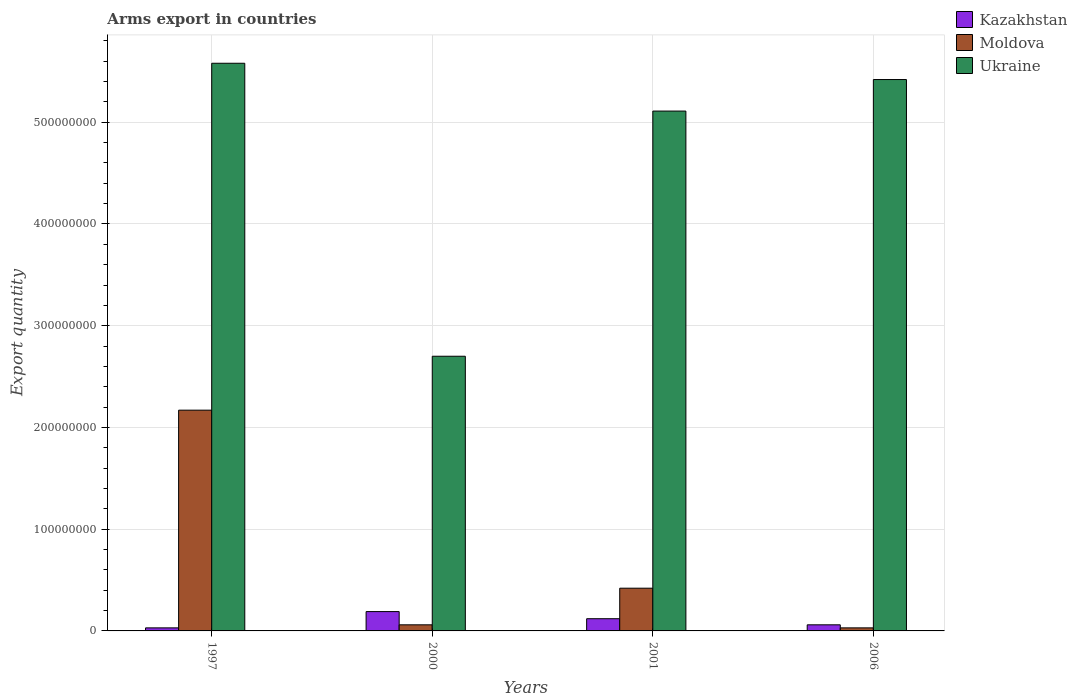In how many cases, is the number of bars for a given year not equal to the number of legend labels?
Offer a terse response. 0. What is the total arms export in Moldova in 2000?
Make the answer very short. 6.00e+06. Across all years, what is the maximum total arms export in Moldova?
Offer a very short reply. 2.17e+08. In which year was the total arms export in Kazakhstan minimum?
Ensure brevity in your answer.  1997. What is the total total arms export in Ukraine in the graph?
Give a very brief answer. 1.88e+09. What is the difference between the total arms export in Ukraine in 2000 and that in 2006?
Provide a short and direct response. -2.72e+08. What is the difference between the total arms export in Ukraine in 2000 and the total arms export in Kazakhstan in 2006?
Your response must be concise. 2.64e+08. What is the average total arms export in Moldova per year?
Your answer should be very brief. 6.70e+07. In the year 2001, what is the difference between the total arms export in Ukraine and total arms export in Kazakhstan?
Your response must be concise. 4.99e+08. What is the ratio of the total arms export in Ukraine in 2001 to that in 2006?
Your response must be concise. 0.94. Is the total arms export in Moldova in 2000 less than that in 2006?
Give a very brief answer. No. Is the difference between the total arms export in Ukraine in 2001 and 2006 greater than the difference between the total arms export in Kazakhstan in 2001 and 2006?
Offer a very short reply. No. What is the difference between the highest and the second highest total arms export in Kazakhstan?
Ensure brevity in your answer.  7.00e+06. What is the difference between the highest and the lowest total arms export in Ukraine?
Your response must be concise. 2.88e+08. In how many years, is the total arms export in Kazakhstan greater than the average total arms export in Kazakhstan taken over all years?
Your answer should be compact. 2. What does the 1st bar from the left in 2000 represents?
Your answer should be very brief. Kazakhstan. What does the 3rd bar from the right in 2000 represents?
Give a very brief answer. Kazakhstan. Are all the bars in the graph horizontal?
Give a very brief answer. No. How many years are there in the graph?
Keep it short and to the point. 4. Are the values on the major ticks of Y-axis written in scientific E-notation?
Make the answer very short. No. Does the graph contain grids?
Offer a terse response. Yes. How are the legend labels stacked?
Your answer should be compact. Vertical. What is the title of the graph?
Give a very brief answer. Arms export in countries. Does "Tanzania" appear as one of the legend labels in the graph?
Make the answer very short. No. What is the label or title of the X-axis?
Offer a very short reply. Years. What is the label or title of the Y-axis?
Your answer should be compact. Export quantity. What is the Export quantity of Moldova in 1997?
Offer a terse response. 2.17e+08. What is the Export quantity in Ukraine in 1997?
Offer a terse response. 5.58e+08. What is the Export quantity of Kazakhstan in 2000?
Keep it short and to the point. 1.90e+07. What is the Export quantity of Moldova in 2000?
Give a very brief answer. 6.00e+06. What is the Export quantity in Ukraine in 2000?
Your answer should be compact. 2.70e+08. What is the Export quantity of Moldova in 2001?
Offer a very short reply. 4.20e+07. What is the Export quantity of Ukraine in 2001?
Give a very brief answer. 5.11e+08. What is the Export quantity of Kazakhstan in 2006?
Ensure brevity in your answer.  6.00e+06. What is the Export quantity of Ukraine in 2006?
Make the answer very short. 5.42e+08. Across all years, what is the maximum Export quantity of Kazakhstan?
Provide a short and direct response. 1.90e+07. Across all years, what is the maximum Export quantity of Moldova?
Your response must be concise. 2.17e+08. Across all years, what is the maximum Export quantity in Ukraine?
Your answer should be compact. 5.58e+08. Across all years, what is the minimum Export quantity in Ukraine?
Offer a very short reply. 2.70e+08. What is the total Export quantity in Kazakhstan in the graph?
Make the answer very short. 4.00e+07. What is the total Export quantity of Moldova in the graph?
Ensure brevity in your answer.  2.68e+08. What is the total Export quantity in Ukraine in the graph?
Ensure brevity in your answer.  1.88e+09. What is the difference between the Export quantity in Kazakhstan in 1997 and that in 2000?
Provide a succinct answer. -1.60e+07. What is the difference between the Export quantity of Moldova in 1997 and that in 2000?
Offer a very short reply. 2.11e+08. What is the difference between the Export quantity of Ukraine in 1997 and that in 2000?
Offer a terse response. 2.88e+08. What is the difference between the Export quantity in Kazakhstan in 1997 and that in 2001?
Give a very brief answer. -9.00e+06. What is the difference between the Export quantity in Moldova in 1997 and that in 2001?
Your answer should be very brief. 1.75e+08. What is the difference between the Export quantity in Ukraine in 1997 and that in 2001?
Give a very brief answer. 4.70e+07. What is the difference between the Export quantity in Moldova in 1997 and that in 2006?
Ensure brevity in your answer.  2.14e+08. What is the difference between the Export quantity in Ukraine in 1997 and that in 2006?
Give a very brief answer. 1.60e+07. What is the difference between the Export quantity of Moldova in 2000 and that in 2001?
Provide a succinct answer. -3.60e+07. What is the difference between the Export quantity of Ukraine in 2000 and that in 2001?
Make the answer very short. -2.41e+08. What is the difference between the Export quantity in Kazakhstan in 2000 and that in 2006?
Offer a very short reply. 1.30e+07. What is the difference between the Export quantity in Moldova in 2000 and that in 2006?
Give a very brief answer. 3.00e+06. What is the difference between the Export quantity in Ukraine in 2000 and that in 2006?
Provide a short and direct response. -2.72e+08. What is the difference between the Export quantity of Kazakhstan in 2001 and that in 2006?
Your answer should be very brief. 6.00e+06. What is the difference between the Export quantity of Moldova in 2001 and that in 2006?
Provide a short and direct response. 3.90e+07. What is the difference between the Export quantity in Ukraine in 2001 and that in 2006?
Offer a very short reply. -3.10e+07. What is the difference between the Export quantity of Kazakhstan in 1997 and the Export quantity of Moldova in 2000?
Provide a short and direct response. -3.00e+06. What is the difference between the Export quantity in Kazakhstan in 1997 and the Export quantity in Ukraine in 2000?
Ensure brevity in your answer.  -2.67e+08. What is the difference between the Export quantity of Moldova in 1997 and the Export quantity of Ukraine in 2000?
Your answer should be very brief. -5.30e+07. What is the difference between the Export quantity of Kazakhstan in 1997 and the Export quantity of Moldova in 2001?
Keep it short and to the point. -3.90e+07. What is the difference between the Export quantity in Kazakhstan in 1997 and the Export quantity in Ukraine in 2001?
Keep it short and to the point. -5.08e+08. What is the difference between the Export quantity of Moldova in 1997 and the Export quantity of Ukraine in 2001?
Provide a short and direct response. -2.94e+08. What is the difference between the Export quantity of Kazakhstan in 1997 and the Export quantity of Ukraine in 2006?
Your answer should be very brief. -5.39e+08. What is the difference between the Export quantity of Moldova in 1997 and the Export quantity of Ukraine in 2006?
Your answer should be compact. -3.25e+08. What is the difference between the Export quantity of Kazakhstan in 2000 and the Export quantity of Moldova in 2001?
Give a very brief answer. -2.30e+07. What is the difference between the Export quantity of Kazakhstan in 2000 and the Export quantity of Ukraine in 2001?
Keep it short and to the point. -4.92e+08. What is the difference between the Export quantity in Moldova in 2000 and the Export quantity in Ukraine in 2001?
Keep it short and to the point. -5.05e+08. What is the difference between the Export quantity in Kazakhstan in 2000 and the Export quantity in Moldova in 2006?
Offer a terse response. 1.60e+07. What is the difference between the Export quantity in Kazakhstan in 2000 and the Export quantity in Ukraine in 2006?
Offer a very short reply. -5.23e+08. What is the difference between the Export quantity in Moldova in 2000 and the Export quantity in Ukraine in 2006?
Keep it short and to the point. -5.36e+08. What is the difference between the Export quantity in Kazakhstan in 2001 and the Export quantity in Moldova in 2006?
Offer a very short reply. 9.00e+06. What is the difference between the Export quantity of Kazakhstan in 2001 and the Export quantity of Ukraine in 2006?
Provide a succinct answer. -5.30e+08. What is the difference between the Export quantity of Moldova in 2001 and the Export quantity of Ukraine in 2006?
Offer a terse response. -5.00e+08. What is the average Export quantity in Moldova per year?
Provide a short and direct response. 6.70e+07. What is the average Export quantity in Ukraine per year?
Your answer should be compact. 4.70e+08. In the year 1997, what is the difference between the Export quantity of Kazakhstan and Export quantity of Moldova?
Offer a very short reply. -2.14e+08. In the year 1997, what is the difference between the Export quantity in Kazakhstan and Export quantity in Ukraine?
Keep it short and to the point. -5.55e+08. In the year 1997, what is the difference between the Export quantity of Moldova and Export quantity of Ukraine?
Your response must be concise. -3.41e+08. In the year 2000, what is the difference between the Export quantity of Kazakhstan and Export quantity of Moldova?
Make the answer very short. 1.30e+07. In the year 2000, what is the difference between the Export quantity in Kazakhstan and Export quantity in Ukraine?
Provide a short and direct response. -2.51e+08. In the year 2000, what is the difference between the Export quantity in Moldova and Export quantity in Ukraine?
Ensure brevity in your answer.  -2.64e+08. In the year 2001, what is the difference between the Export quantity of Kazakhstan and Export quantity of Moldova?
Ensure brevity in your answer.  -3.00e+07. In the year 2001, what is the difference between the Export quantity of Kazakhstan and Export quantity of Ukraine?
Provide a succinct answer. -4.99e+08. In the year 2001, what is the difference between the Export quantity in Moldova and Export quantity in Ukraine?
Offer a terse response. -4.69e+08. In the year 2006, what is the difference between the Export quantity in Kazakhstan and Export quantity in Ukraine?
Provide a short and direct response. -5.36e+08. In the year 2006, what is the difference between the Export quantity of Moldova and Export quantity of Ukraine?
Your answer should be very brief. -5.39e+08. What is the ratio of the Export quantity in Kazakhstan in 1997 to that in 2000?
Your answer should be very brief. 0.16. What is the ratio of the Export quantity of Moldova in 1997 to that in 2000?
Ensure brevity in your answer.  36.17. What is the ratio of the Export quantity in Ukraine in 1997 to that in 2000?
Make the answer very short. 2.07. What is the ratio of the Export quantity of Moldova in 1997 to that in 2001?
Offer a very short reply. 5.17. What is the ratio of the Export quantity in Ukraine in 1997 to that in 2001?
Your answer should be very brief. 1.09. What is the ratio of the Export quantity of Moldova in 1997 to that in 2006?
Make the answer very short. 72.33. What is the ratio of the Export quantity of Ukraine in 1997 to that in 2006?
Your response must be concise. 1.03. What is the ratio of the Export quantity of Kazakhstan in 2000 to that in 2001?
Keep it short and to the point. 1.58. What is the ratio of the Export quantity of Moldova in 2000 to that in 2001?
Keep it short and to the point. 0.14. What is the ratio of the Export quantity of Ukraine in 2000 to that in 2001?
Your answer should be very brief. 0.53. What is the ratio of the Export quantity of Kazakhstan in 2000 to that in 2006?
Offer a very short reply. 3.17. What is the ratio of the Export quantity in Ukraine in 2000 to that in 2006?
Make the answer very short. 0.5. What is the ratio of the Export quantity of Kazakhstan in 2001 to that in 2006?
Make the answer very short. 2. What is the ratio of the Export quantity of Moldova in 2001 to that in 2006?
Give a very brief answer. 14. What is the ratio of the Export quantity of Ukraine in 2001 to that in 2006?
Your answer should be compact. 0.94. What is the difference between the highest and the second highest Export quantity in Moldova?
Your response must be concise. 1.75e+08. What is the difference between the highest and the second highest Export quantity of Ukraine?
Offer a terse response. 1.60e+07. What is the difference between the highest and the lowest Export quantity of Kazakhstan?
Your answer should be compact. 1.60e+07. What is the difference between the highest and the lowest Export quantity in Moldova?
Ensure brevity in your answer.  2.14e+08. What is the difference between the highest and the lowest Export quantity of Ukraine?
Make the answer very short. 2.88e+08. 